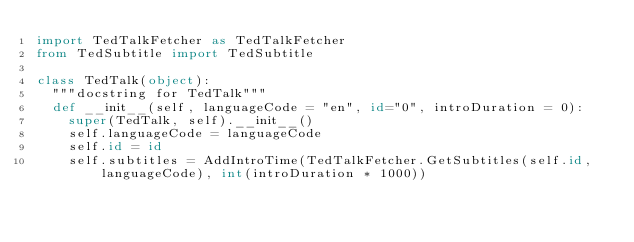Convert code to text. <code><loc_0><loc_0><loc_500><loc_500><_Python_>import TedTalkFetcher as TedTalkFetcher
from TedSubtitle import TedSubtitle

class TedTalk(object):
  """docstring for TedTalk"""
  def __init__(self, languageCode = "en", id="0", introDuration = 0):
    super(TedTalk, self).__init__() 
    self.languageCode = languageCode
    self.id = id 
    self.subtitles = AddIntroTime(TedTalkFetcher.GetSubtitles(self.id, languageCode), int(introDuration * 1000))
  </code> 